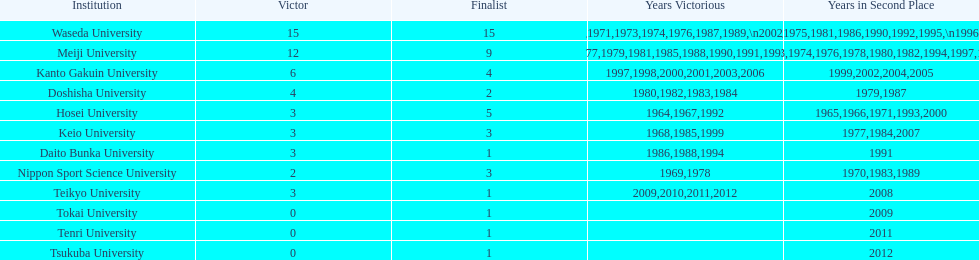Who emerged as the winner in the subsequent year? Waseda University. 